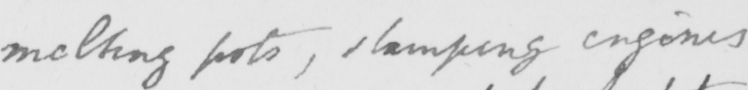Please provide the text content of this handwritten line. melting pots , stamping engines 